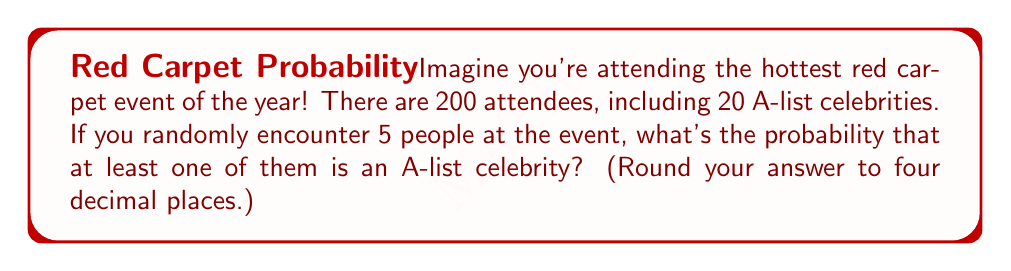Could you help me with this problem? Let's approach this step-by-step:

1) First, we need to calculate the probability of not encountering an A-list celebrity in a single encounter:

   $P(\text{not celebrity}) = \frac{180}{200} = 0.9$

2) Now, for all 5 encounters to not be with a celebrity, this needs to happen 5 times in a row:

   $P(\text{no celebrity in 5 encounters}) = (0.9)^5 = 0.59049$

3) Therefore, the probability of encountering at least one celebrity is the opposite of encountering no celebrities:

   $P(\text{at least one celebrity}) = 1 - P(\text{no celebrity in 5 encounters})$

   $= 1 - 0.59049 = 0.40951$

4) Rounding to four decimal places:

   $0.40951 \approx 0.4095$

This means there's about a 40.95% chance of encountering at least one A-list celebrity in your 5 random encounters at the event!
Answer: $0.4095$ 